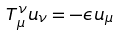Convert formula to latex. <formula><loc_0><loc_0><loc_500><loc_500>T _ { \mu } ^ { \nu } u _ { \nu } = - \epsilon u _ { \mu }</formula> 